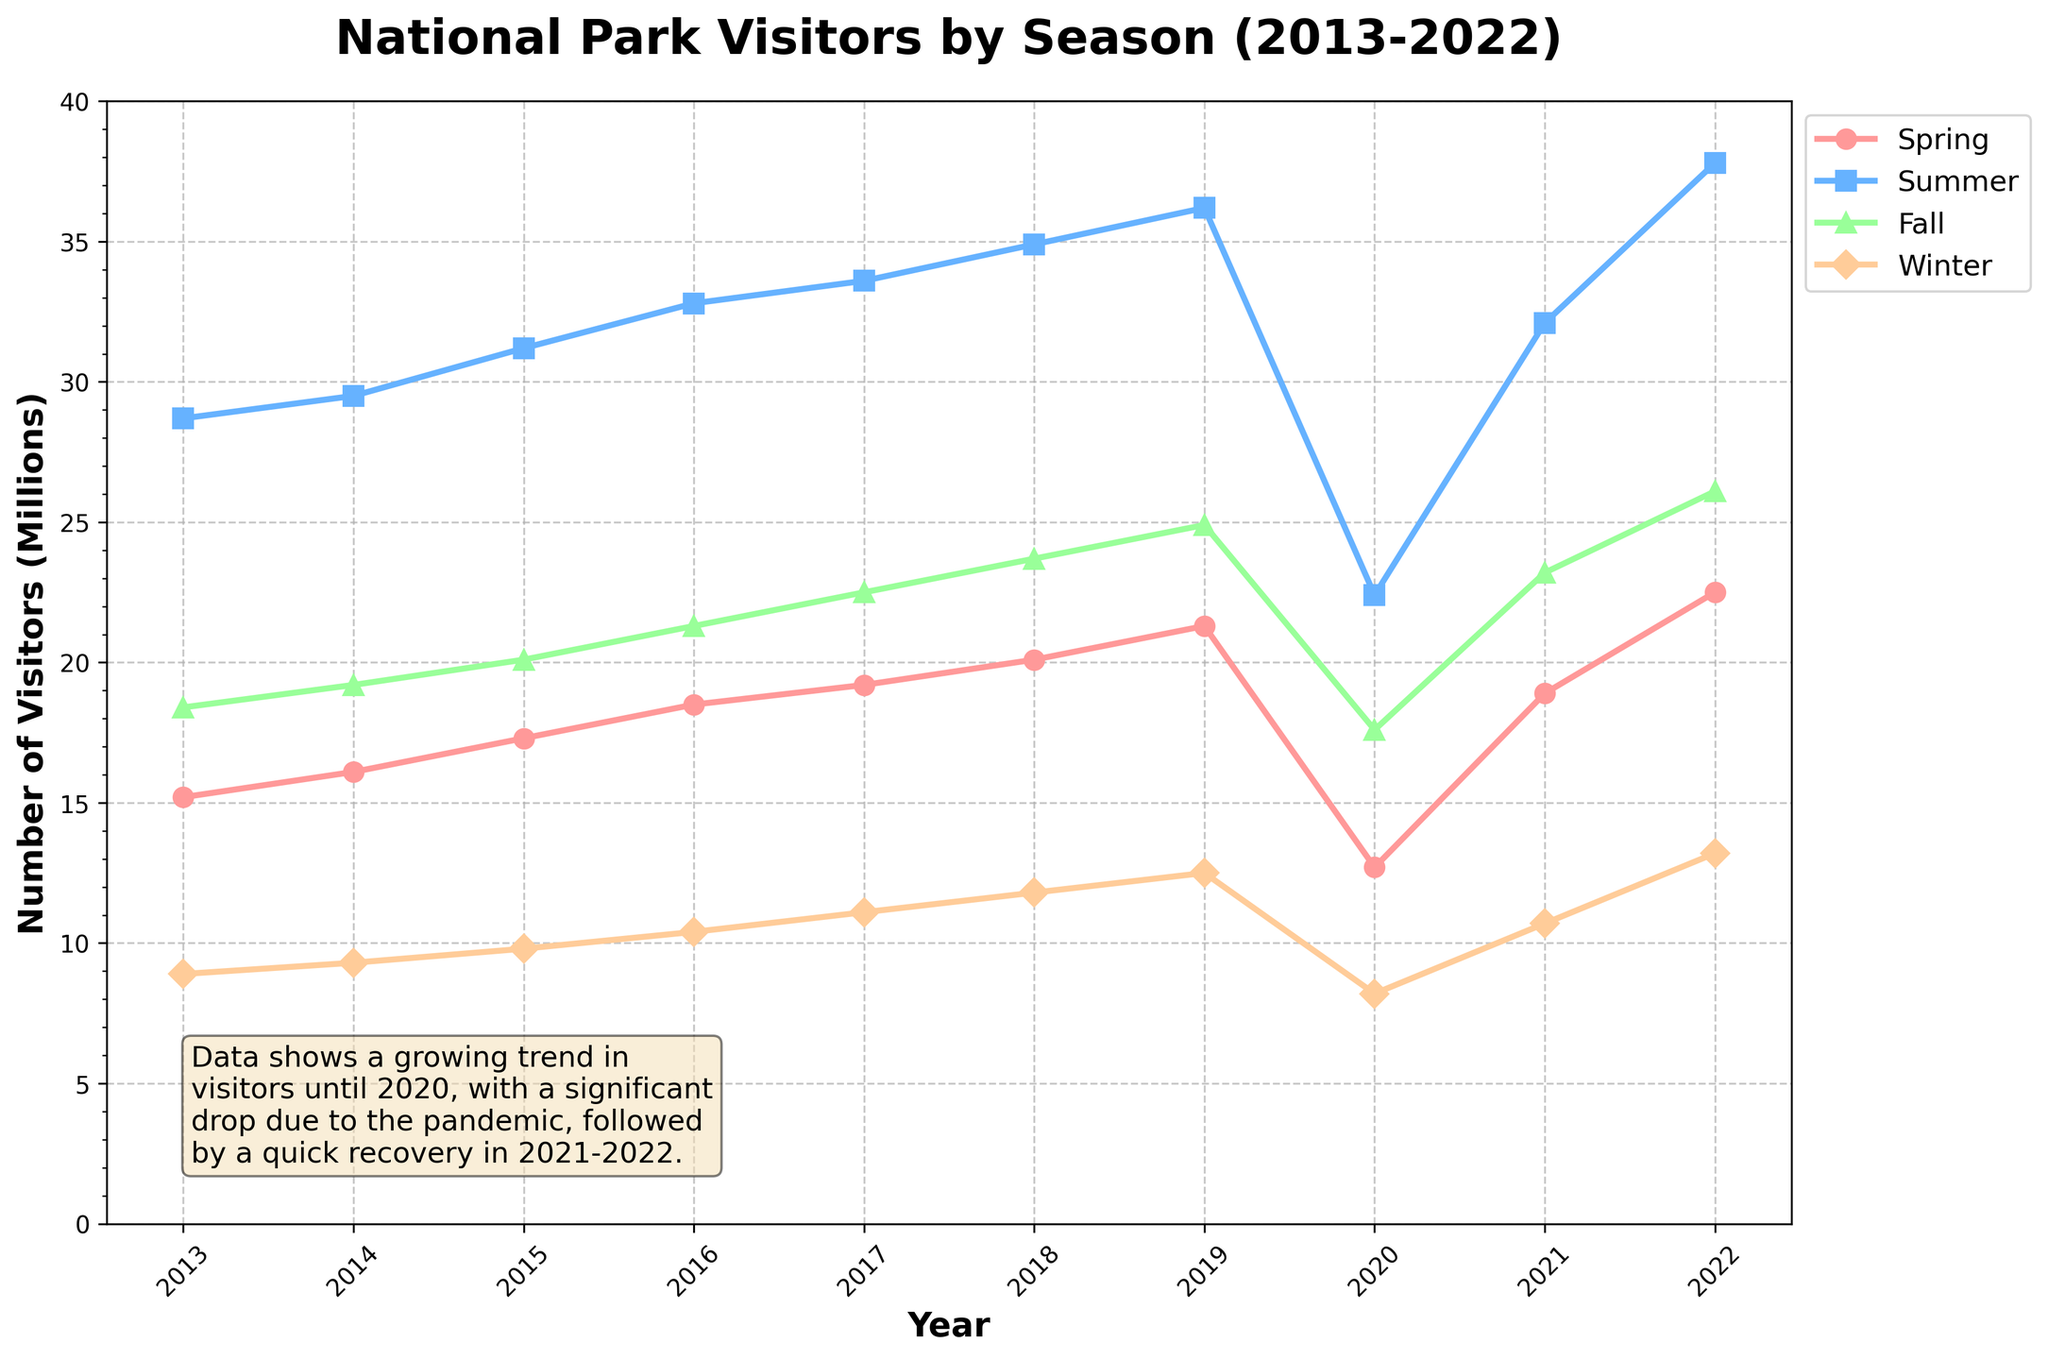Which season had the highest number of visitors in 2022? Look at the data points for 2022 and compare the values of different seasons. The season with the highest value represents the highest number of visitors. Summer has the highest value of 37.8 million visitors.
Answer: Summer Which year had the most significant drop in visitors across all seasons? Examine the trends for each season and identify the year with the largest decline from the previous year. In 2020, every season shows a marked decrease in visitors, indicating the most significant drop.
Answer: 2020 What is the average number of visitors in Spring over the entire decade? Add the number of visitors for Spring from 2013 to 2022 and divide by the number of years (10). The calculation is (15.2 + 16.1 + 17.3 + 18.5 + 19.2 + 20.1 + 21.3 + 12.7 + 18.9 + 22.5)/10, which equals 18.18.
Answer: 18.18 Compare the growth in visitors from 2015 to 2019 for Summer and Winter. Which season had a higher increase? Calculate the difference in the number of visitors between 2015 and 2019 for both Summer and Winter. For Summer: 36.2 - 31.2 = 5.0 million. For Winter: 12.5 - 9.8 = 2.7 million. Summer had a higher increase.
Answer: Summer In which season did visitors return to pre-2020 levels the quickest? Identify the pre-2020 peak and compare it to 2021 and 2022 values for each season. Spring visitors returned to pre-2020 levels (19.2 in 2017) by 2021 (18.9), indicating the quickest return.
Answer: Spring Which season showed the least variability in visitor numbers from 2013 to 2022? Look at the range (maximum - minimum) of visitor numbers for each season. Winter numbers range from 8.2 to 13.2, a range of 5.0. This is the smallest range compared to other seasons.
Answer: Winter 